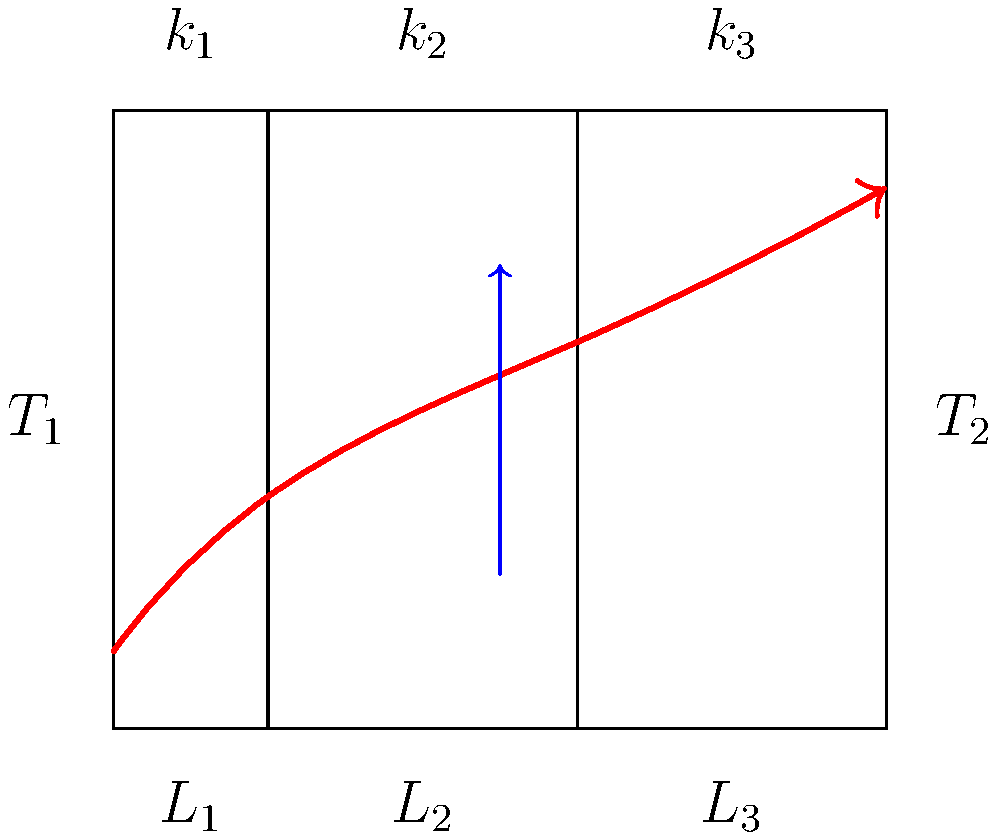As a community organizer working on sustainable housing initiatives, you're tasked with improving the energy efficiency of low-income homes. Consider a wall with three layers of different materials, as shown in the diagram. The inner temperature $T_1$ is 20°C, and the outer temperature $T_2$ is -5°C. The thermal conductivities ($k_1$, $k_2$, $k_3$) are 0.5, 0.03, and 0.8 W/m·K, respectively. The thicknesses ($L_1$, $L_2$, $L_3$) are 0.1, 0.05, and 0.15 m, respectively. Calculate the rate of heat transfer per unit area through this wall. To solve this problem, we'll use the concept of thermal resistance in series for a multi-layered wall. Here's a step-by-step approach:

1) The heat transfer rate per unit area (q) is given by:
   $q = \frac{T_1 - T_2}{R_{total}}$

   where $R_{total}$ is the total thermal resistance of the wall.

2) For layers in series, $R_{total} = R_1 + R_2 + R_3$

3) The thermal resistance for each layer is given by $R = \frac{L}{k}$

4) Calculate the resistance for each layer:
   $R_1 = \frac{L_1}{k_1} = \frac{0.1}{0.5} = 0.2$ m²·K/W
   $R_2 = \frac{L_2}{k_2} = \frac{0.05}{0.03} = 1.667$ m²·K/W
   $R_3 = \frac{L_3}{k_3} = \frac{0.15}{0.8} = 0.1875$ m²·K/W

5) Calculate the total resistance:
   $R_{total} = 0.2 + 1.667 + 0.1875 = 2.0545$ m²·K/W

6) Now we can calculate the heat transfer rate:
   $q = \frac{T_1 - T_2}{R_{total}} = \frac{20 - (-5)}{2.0545} = 12.17$ W/m²

Therefore, the rate of heat transfer per unit area through the wall is approximately 12.17 W/m².
Answer: 12.17 W/m² 